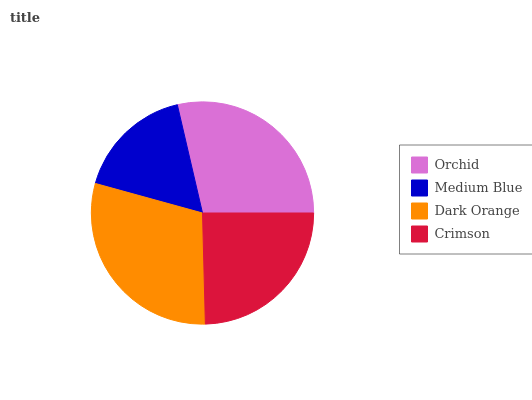Is Medium Blue the minimum?
Answer yes or no. Yes. Is Dark Orange the maximum?
Answer yes or no. Yes. Is Dark Orange the minimum?
Answer yes or no. No. Is Medium Blue the maximum?
Answer yes or no. No. Is Dark Orange greater than Medium Blue?
Answer yes or no. Yes. Is Medium Blue less than Dark Orange?
Answer yes or no. Yes. Is Medium Blue greater than Dark Orange?
Answer yes or no. No. Is Dark Orange less than Medium Blue?
Answer yes or no. No. Is Orchid the high median?
Answer yes or no. Yes. Is Crimson the low median?
Answer yes or no. Yes. Is Crimson the high median?
Answer yes or no. No. Is Orchid the low median?
Answer yes or no. No. 